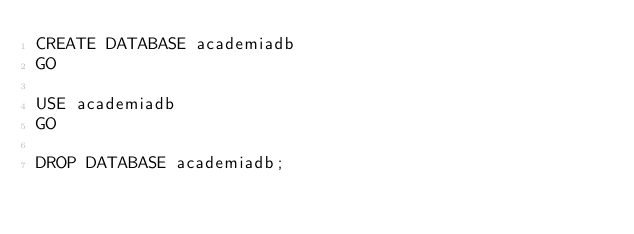Convert code to text. <code><loc_0><loc_0><loc_500><loc_500><_SQL_>CREATE DATABASE academiadb 
GO

USE academiadb
GO

DROP DATABASE academiadb;</code> 